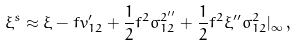Convert formula to latex. <formula><loc_0><loc_0><loc_500><loc_500>\xi ^ { s } \approx \xi - f v _ { 1 2 } ^ { \prime } + \frac { 1 } { 2 } f ^ { 2 } \sigma _ { 1 2 } ^ { 2 ^ { \prime \prime } } + \frac { 1 } { 2 } f ^ { 2 } \xi ^ { \prime \prime } \sigma _ { 1 2 } ^ { 2 } | _ { \infty } \, ,</formula> 